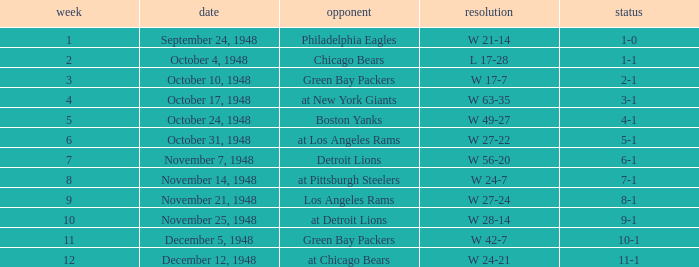What was the record for December 5, 1948? 10-1. 